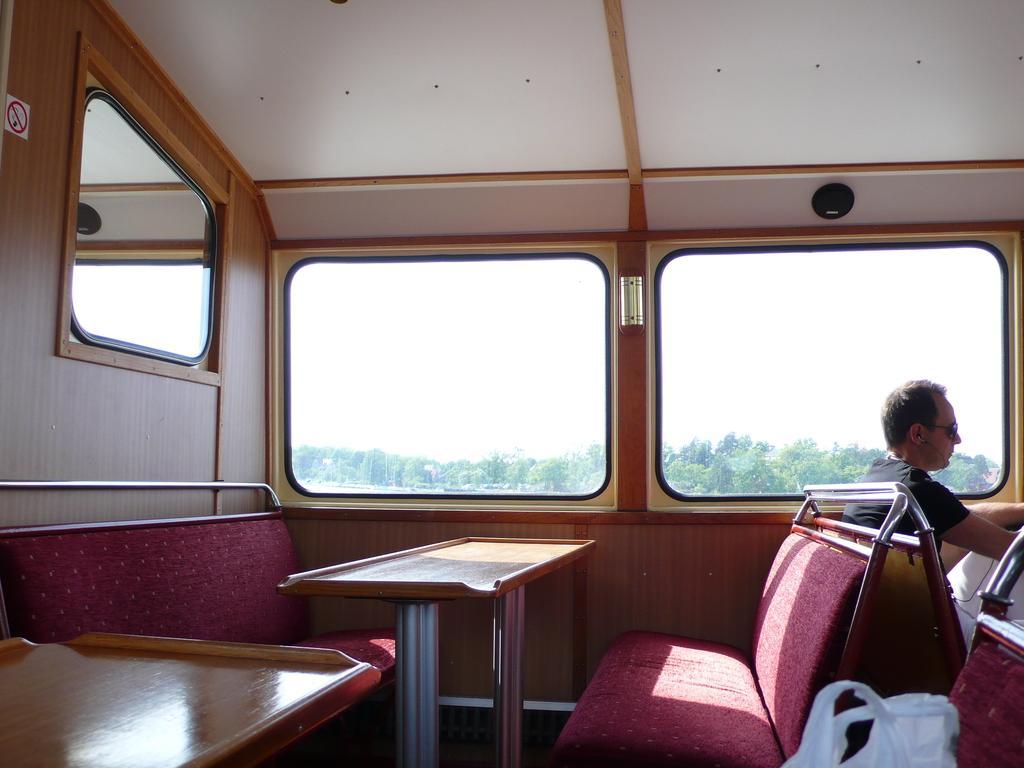How would you summarize this image in a sentence or two? On the left side of the image we can see a glass window, seat and a no smoking board. In the middle of the image we can see a table, seat, glass window, trees and the sky. On the right side of the image we can see a person is sitting on the seat. 